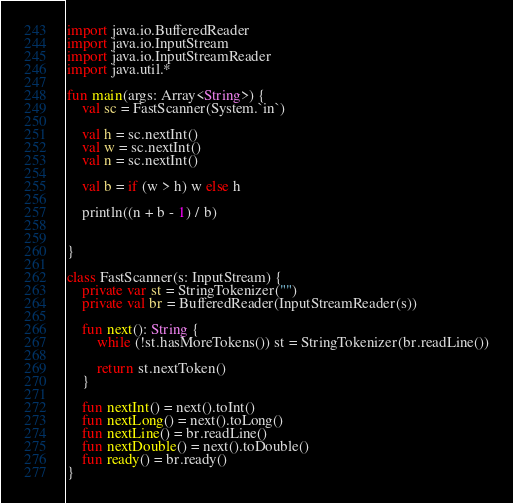Convert code to text. <code><loc_0><loc_0><loc_500><loc_500><_Kotlin_>import java.io.BufferedReader
import java.io.InputStream
import java.io.InputStreamReader
import java.util.*

fun main(args: Array<String>) {
    val sc = FastScanner(System.`in`)

    val h = sc.nextInt()
    val w = sc.nextInt()
    val n = sc.nextInt()

    val b = if (w > h) w else h

    println((n + b - 1) / b)


}

class FastScanner(s: InputStream) {
    private var st = StringTokenizer("")
    private val br = BufferedReader(InputStreamReader(s))

    fun next(): String {
        while (!st.hasMoreTokens()) st = StringTokenizer(br.readLine())

        return st.nextToken()
    }

    fun nextInt() = next().toInt()
    fun nextLong() = next().toLong()
    fun nextLine() = br.readLine()
    fun nextDouble() = next().toDouble()
    fun ready() = br.ready()
}</code> 